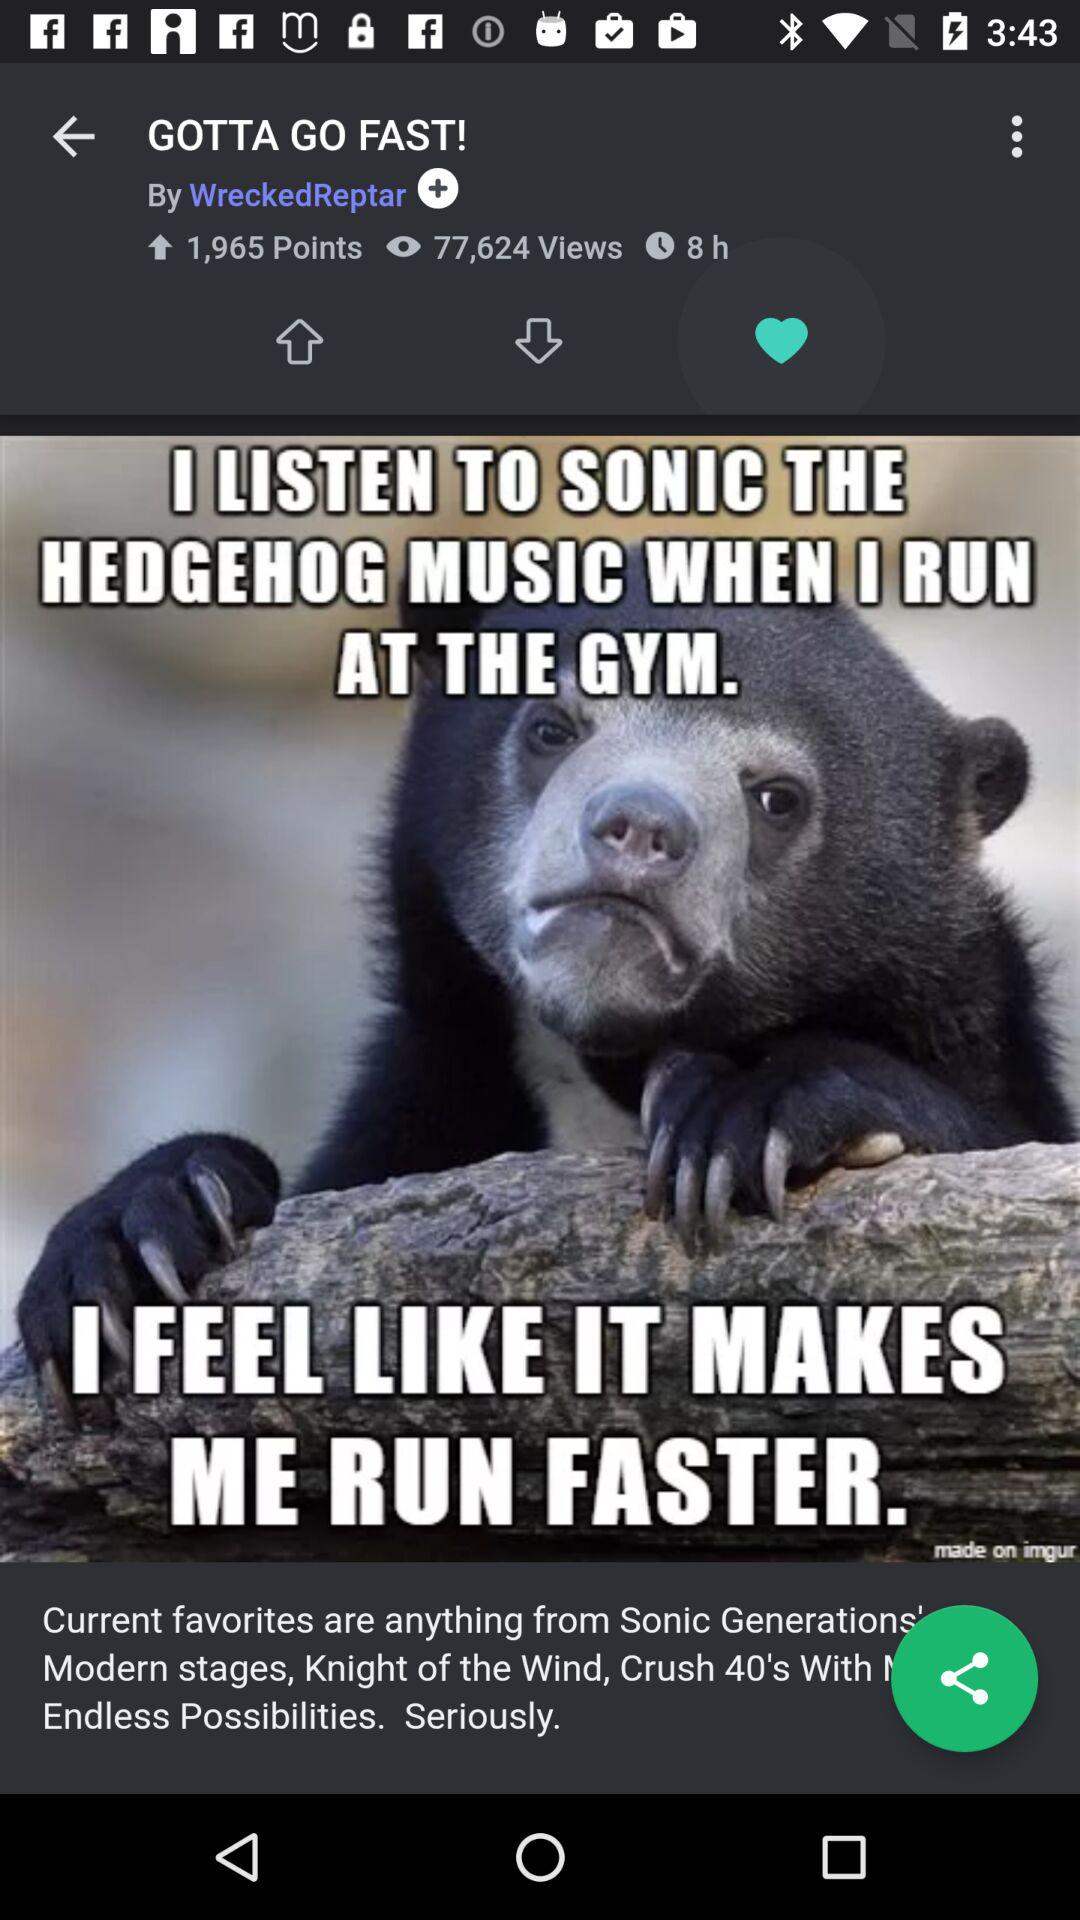How many more views does the post have than points?
Answer the question using a single word or phrase. 75659 